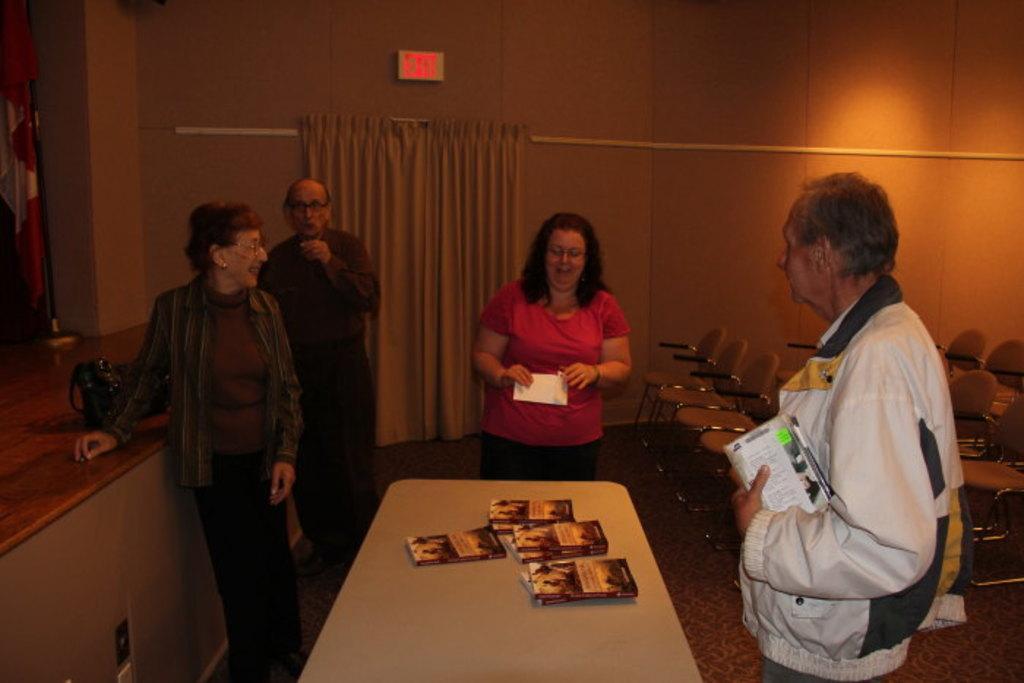Can you describe this image briefly? There are four persons standing and there is a table in front of them, Which contains books on it and there are chairs in the background. 